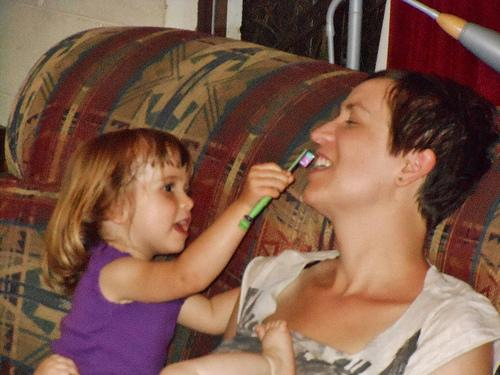Describe the couch in the image. The couch is multicolored, featuring red, gold, black, blue, and white colors. Identify the two people in the image and what they are doing. The image features a woman with short hair sitting on a multicolored couch and a little girl with long hair trying to brush the woman's teeth. Please describe what the woman sitting is wearing, and the color of her hair. The woman is wearing a white and grey short-sleeve blouse, and she has short black hair. Describe the appearance of the little girl in the image and her action. The little girl has brown hair, blue eyes, long eyelids, is wearing a purple short sleeve sweater, and is holding a toothbrush to the woman's mouth. What emotion is the woman portraying in the image? The woman appears to be smiling or laughing, indicating happiness. What is the small girl trying to do in the image? The little girl is trying to brush the woman's teeth with a green toothbrush. Discuss an interaction observed between the little girl and the woman in the image. An interaction observed in the image is the little girl trying to brush the woman's teeth with a green toothbrush, while the woman is smiling. Mention an accessory the woman in the image has. The woman has tiny earrings in her pierced ear. Count the number of toothbrushes in the image and describe their appearance. There are two toothbrushes in the image: a green one with a black marking, and another green one without marking. Describe the little girl's attire and what is she holding in her hand? The little girl is wearing a purple short sleeve sweater and is holding a green toothbrush in her hand. 